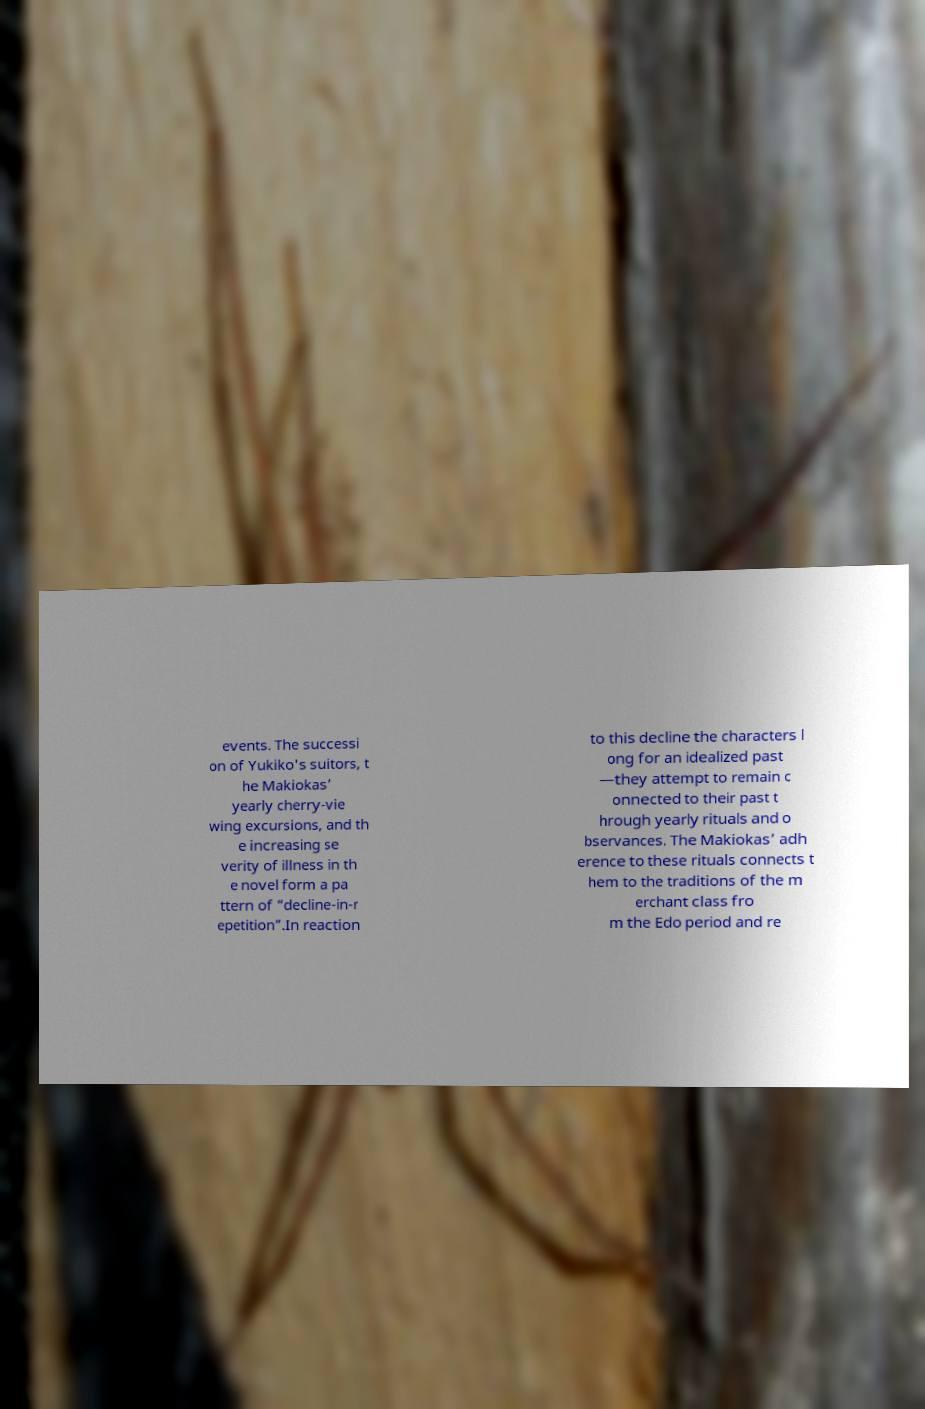Please identify and transcribe the text found in this image. events. The successi on of Yukiko's suitors, t he Makiokas’ yearly cherry-vie wing excursions, and th e increasing se verity of illness in th e novel form a pa ttern of “decline-in-r epetition”.In reaction to this decline the characters l ong for an idealized past —they attempt to remain c onnected to their past t hrough yearly rituals and o bservances. The Makiokas’ adh erence to these rituals connects t hem to the traditions of the m erchant class fro m the Edo period and re 